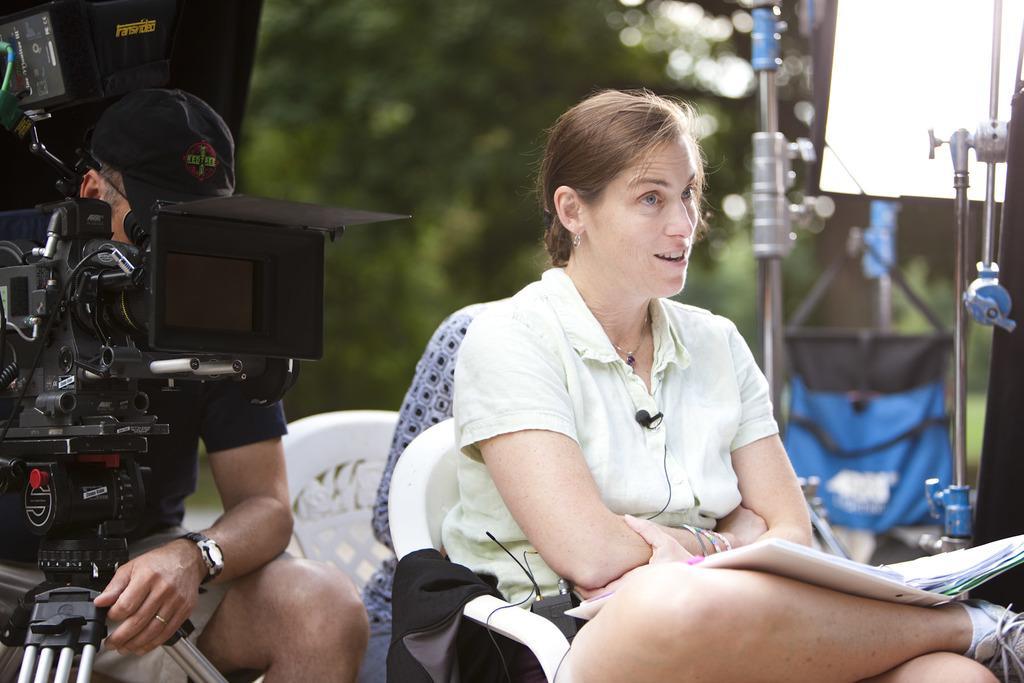How would you summarize this image in a sentence or two? In this image I can see two persons sitting on the chairs. The person in front wearing white shirt and holding few papers. I can also see a camera, background I can see trees in green color 